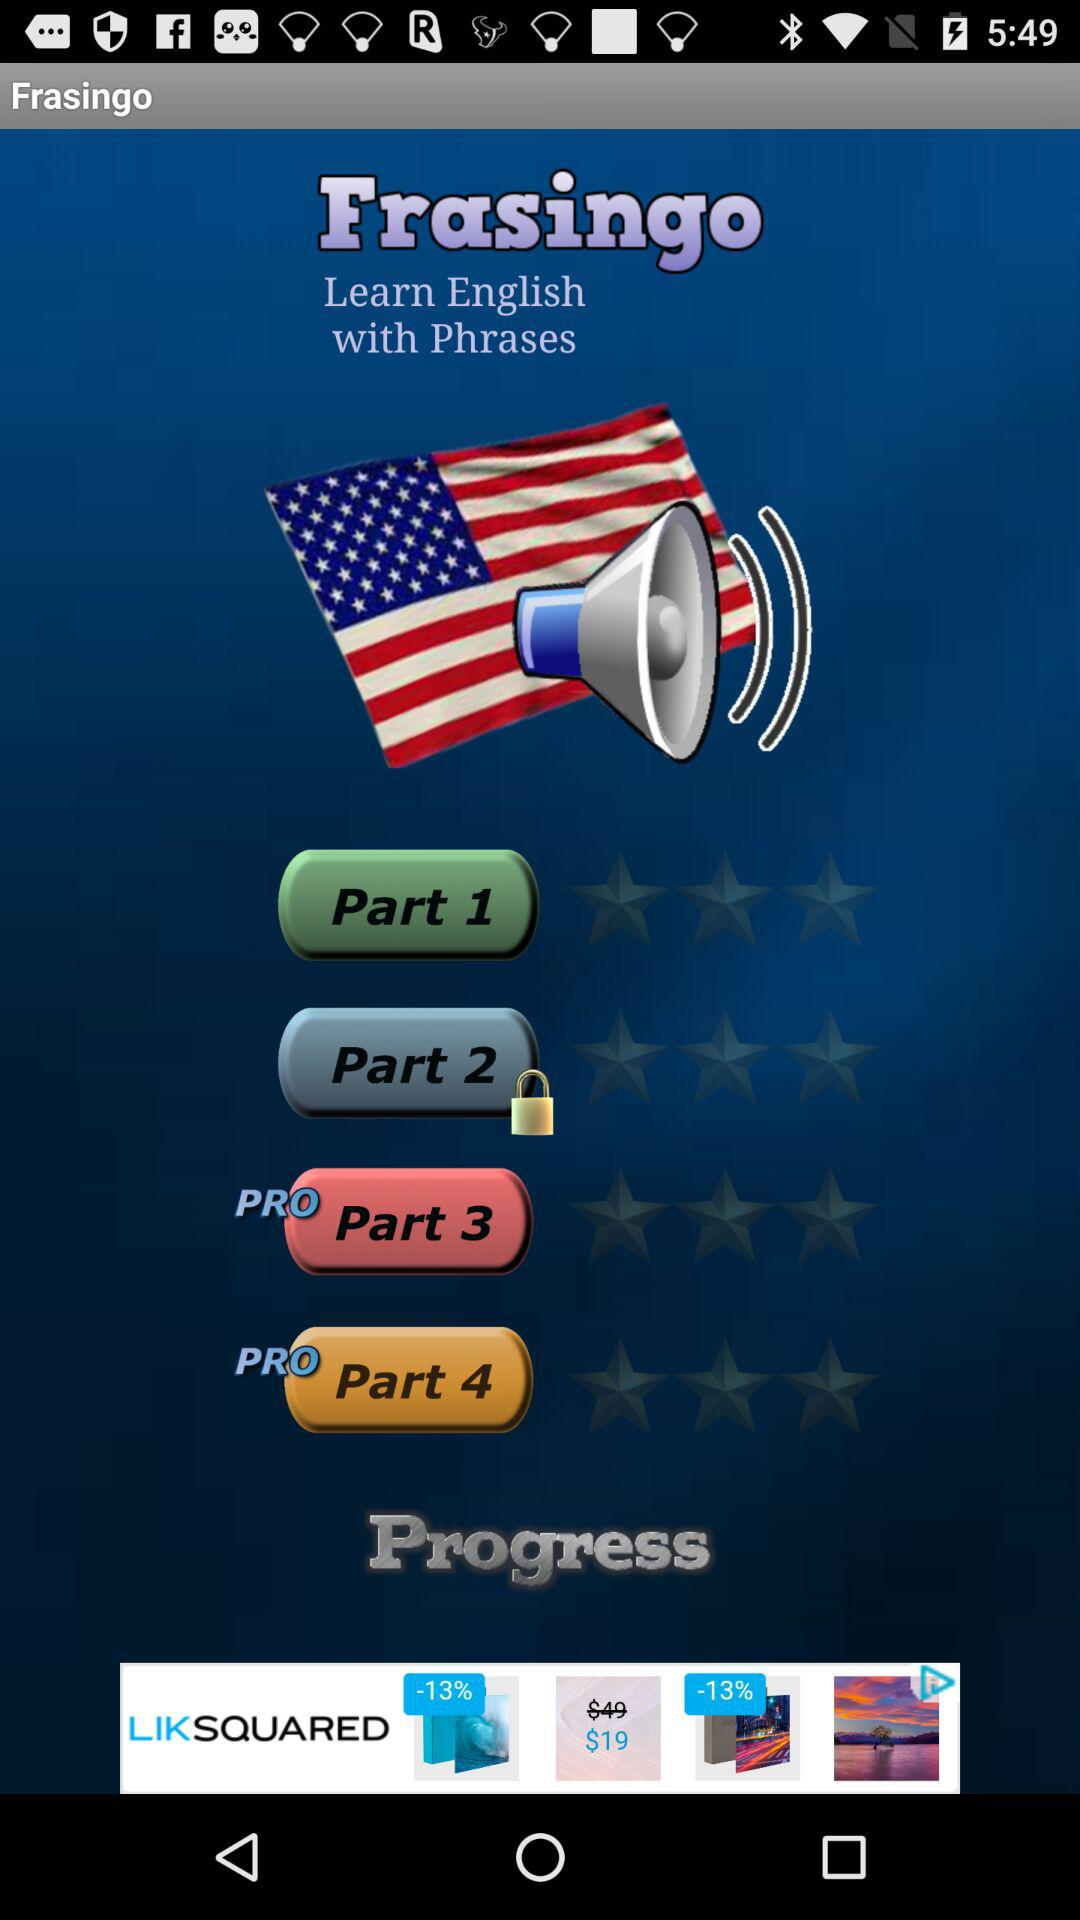Which part is locked? The locked part is 2. 